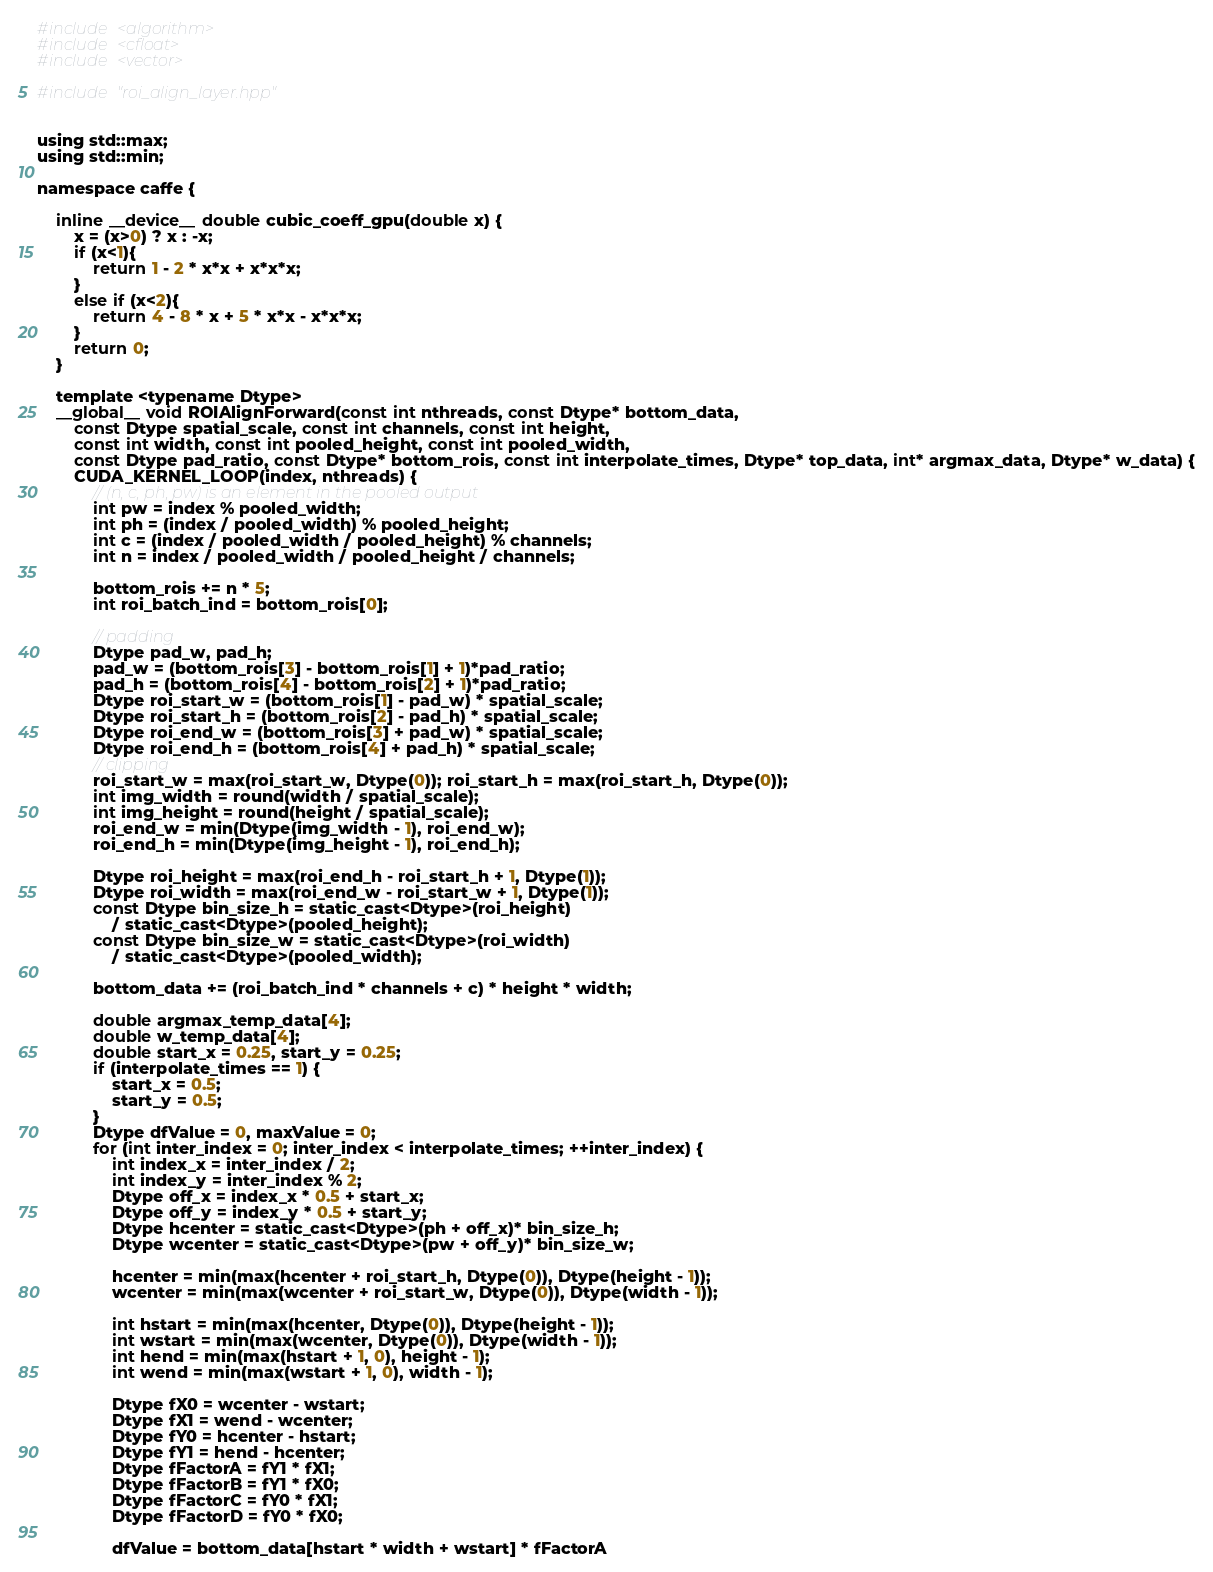Convert code to text. <code><loc_0><loc_0><loc_500><loc_500><_Cuda_>#include <algorithm>
#include <cfloat>
#include <vector>

#include "roi_align_layer.hpp"


using std::max;
using std::min;

namespace caffe {

	inline __device__ double cubic_coeff_gpu(double x) {
		x = (x>0) ? x : -x;
		if (x<1){
			return 1 - 2 * x*x + x*x*x;
		}
		else if (x<2){
			return 4 - 8 * x + 5 * x*x - x*x*x;
		}
		return 0;
	}

	template <typename Dtype>
	__global__ void ROIAlignForward(const int nthreads, const Dtype* bottom_data,
		const Dtype spatial_scale, const int channels, const int height,
		const int width, const int pooled_height, const int pooled_width,
		const Dtype pad_ratio, const Dtype* bottom_rois, const int interpolate_times, Dtype* top_data, int* argmax_data, Dtype* w_data) {
		CUDA_KERNEL_LOOP(index, nthreads) {
			// (n, c, ph, pw) is an element in the pooled output
			int pw = index % pooled_width;
			int ph = (index / pooled_width) % pooled_height;
			int c = (index / pooled_width / pooled_height) % channels;
			int n = index / pooled_width / pooled_height / channels;

			bottom_rois += n * 5;
			int roi_batch_ind = bottom_rois[0];

			// padding
			Dtype pad_w, pad_h;
			pad_w = (bottom_rois[3] - bottom_rois[1] + 1)*pad_ratio;
			pad_h = (bottom_rois[4] - bottom_rois[2] + 1)*pad_ratio;
			Dtype roi_start_w = (bottom_rois[1] - pad_w) * spatial_scale;
			Dtype roi_start_h = (bottom_rois[2] - pad_h) * spatial_scale;
			Dtype roi_end_w = (bottom_rois[3] + pad_w) * spatial_scale;
			Dtype roi_end_h = (bottom_rois[4] + pad_h) * spatial_scale;
			// clipping
			roi_start_w = max(roi_start_w, Dtype(0)); roi_start_h = max(roi_start_h, Dtype(0));
			int img_width = round(width / spatial_scale);
			int img_height = round(height / spatial_scale);
			roi_end_w = min(Dtype(img_width - 1), roi_end_w);
			roi_end_h = min(Dtype(img_height - 1), roi_end_h);

			Dtype roi_height = max(roi_end_h - roi_start_h + 1, Dtype(1));
			Dtype roi_width = max(roi_end_w - roi_start_w + 1, Dtype(1));
			const Dtype bin_size_h = static_cast<Dtype>(roi_height)
				/ static_cast<Dtype>(pooled_height);
			const Dtype bin_size_w = static_cast<Dtype>(roi_width)
				/ static_cast<Dtype>(pooled_width);

			bottom_data += (roi_batch_ind * channels + c) * height * width;

			double argmax_temp_data[4];
			double w_temp_data[4];
			double start_x = 0.25, start_y = 0.25;
			if (interpolate_times == 1) {
				start_x = 0.5;
				start_y = 0.5;
			}
			Dtype dfValue = 0, maxValue = 0;
			for (int inter_index = 0; inter_index < interpolate_times; ++inter_index) {
				int index_x = inter_index / 2;
				int index_y = inter_index % 2;
				Dtype off_x = index_x * 0.5 + start_x;
				Dtype off_y = index_y * 0.5 + start_y;
				Dtype hcenter = static_cast<Dtype>(ph + off_x)* bin_size_h;
				Dtype wcenter = static_cast<Dtype>(pw + off_y)* bin_size_w;

				hcenter = min(max(hcenter + roi_start_h, Dtype(0)), Dtype(height - 1));
				wcenter = min(max(wcenter + roi_start_w, Dtype(0)), Dtype(width - 1));

				int hstart = min(max(hcenter, Dtype(0)), Dtype(height - 1));
				int wstart = min(max(wcenter, Dtype(0)), Dtype(width - 1));
				int hend = min(max(hstart + 1, 0), height - 1);
				int wend = min(max(wstart + 1, 0), width - 1);

				Dtype fX0 = wcenter - wstart;
				Dtype fX1 = wend - wcenter;
				Dtype fY0 = hcenter - hstart;
				Dtype fY1 = hend - hcenter;
				Dtype fFactorA = fY1 * fX1;
				Dtype fFactorB = fY1 * fX0;
				Dtype fFactorC = fY0 * fX1;
				Dtype fFactorD = fY0 * fX0;

				dfValue = bottom_data[hstart * width + wstart] * fFactorA</code> 